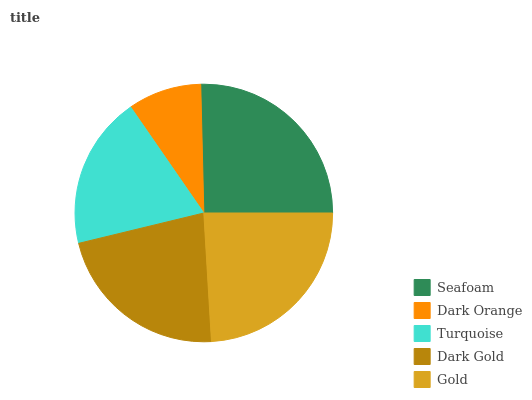Is Dark Orange the minimum?
Answer yes or no. Yes. Is Seafoam the maximum?
Answer yes or no. Yes. Is Turquoise the minimum?
Answer yes or no. No. Is Turquoise the maximum?
Answer yes or no. No. Is Turquoise greater than Dark Orange?
Answer yes or no. Yes. Is Dark Orange less than Turquoise?
Answer yes or no. Yes. Is Dark Orange greater than Turquoise?
Answer yes or no. No. Is Turquoise less than Dark Orange?
Answer yes or no. No. Is Dark Gold the high median?
Answer yes or no. Yes. Is Dark Gold the low median?
Answer yes or no. Yes. Is Dark Orange the high median?
Answer yes or no. No. Is Dark Orange the low median?
Answer yes or no. No. 